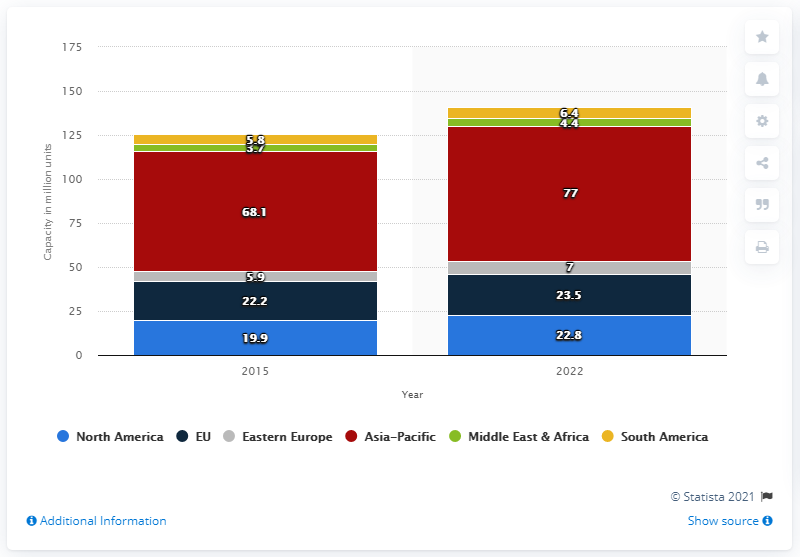Outline some significant characteristics in this image. According to projections, the capacity of the North American automobile industry is expected to reach 22.8 in 2022. 